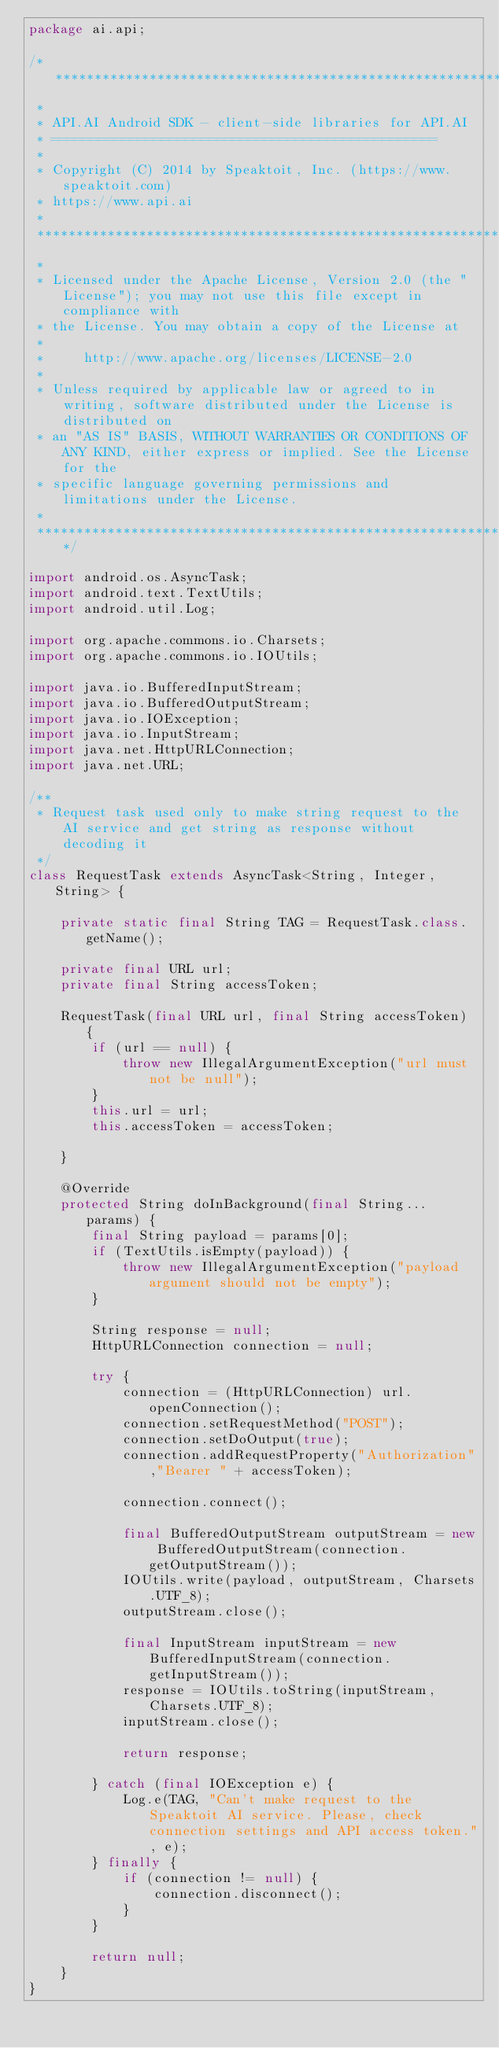Convert code to text. <code><loc_0><loc_0><loc_500><loc_500><_Java_>package ai.api;

/***********************************************************************************************************************
 *
 * API.AI Android SDK - client-side libraries for API.AI
 * =================================================
 *
 * Copyright (C) 2014 by Speaktoit, Inc. (https://www.speaktoit.com)
 * https://www.api.ai
 *
 ***********************************************************************************************************************
 *
 * Licensed under the Apache License, Version 2.0 (the "License"); you may not use this file except in compliance with
 * the License. You may obtain a copy of the License at
 *
 *     http://www.apache.org/licenses/LICENSE-2.0
 *
 * Unless required by applicable law or agreed to in writing, software distributed under the License is distributed on
 * an "AS IS" BASIS, WITHOUT WARRANTIES OR CONDITIONS OF ANY KIND, either express or implied. See the License for the
 * specific language governing permissions and limitations under the License.
 *
 ***********************************************************************************************************************/

import android.os.AsyncTask;
import android.text.TextUtils;
import android.util.Log;

import org.apache.commons.io.Charsets;
import org.apache.commons.io.IOUtils;

import java.io.BufferedInputStream;
import java.io.BufferedOutputStream;
import java.io.IOException;
import java.io.InputStream;
import java.net.HttpURLConnection;
import java.net.URL;

/**
 * Request task used only to make string request to the AI service and get string as response without decoding it
 */
class RequestTask extends AsyncTask<String, Integer, String> {

    private static final String TAG = RequestTask.class.getName();

    private final URL url;
    private final String accessToken;

    RequestTask(final URL url, final String accessToken) {
        if (url == null) {
            throw new IllegalArgumentException("url must not be null");
        }
        this.url = url;
        this.accessToken = accessToken;

    }

    @Override
    protected String doInBackground(final String... params) {
        final String payload = params[0];
        if (TextUtils.isEmpty(payload)) {
            throw new IllegalArgumentException("payload argument should not be empty");
        }

        String response = null;
        HttpURLConnection connection = null;

        try {
            connection = (HttpURLConnection) url.openConnection();
            connection.setRequestMethod("POST");
            connection.setDoOutput(true);
            connection.addRequestProperty("Authorization","Bearer " + accessToken);

            connection.connect();

            final BufferedOutputStream outputStream = new BufferedOutputStream(connection.getOutputStream());
            IOUtils.write(payload, outputStream, Charsets.UTF_8);
            outputStream.close();

            final InputStream inputStream = new BufferedInputStream(connection.getInputStream());
            response = IOUtils.toString(inputStream, Charsets.UTF_8);
            inputStream.close();

            return response;

        } catch (final IOException e) {
            Log.e(TAG, "Can't make request to the Speaktoit AI service. Please, check connection settings and API access token.", e);
        } finally {
            if (connection != null) {
                connection.disconnect();
            }
        }

        return null;
    }
}
</code> 